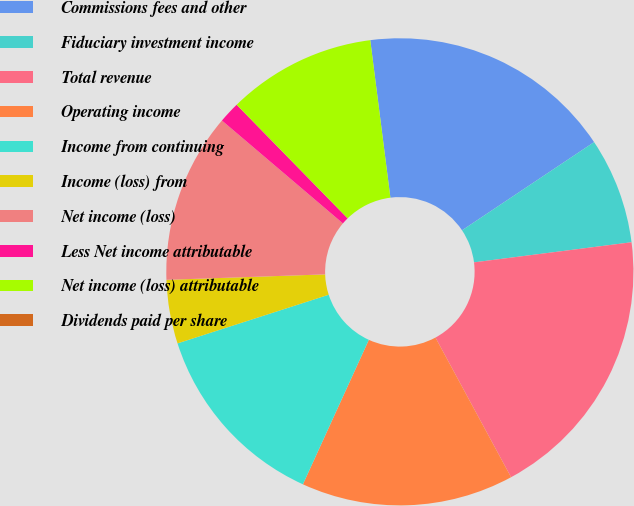Convert chart to OTSL. <chart><loc_0><loc_0><loc_500><loc_500><pie_chart><fcel>Commissions fees and other<fcel>Fiduciary investment income<fcel>Total revenue<fcel>Operating income<fcel>Income from continuing<fcel>Income (loss) from<fcel>Net income (loss)<fcel>Less Net income attributable<fcel>Net income (loss) attributable<fcel>Dividends paid per share<nl><fcel>17.65%<fcel>7.35%<fcel>19.12%<fcel>14.71%<fcel>13.23%<fcel>4.41%<fcel>11.76%<fcel>1.47%<fcel>10.29%<fcel>0.0%<nl></chart> 